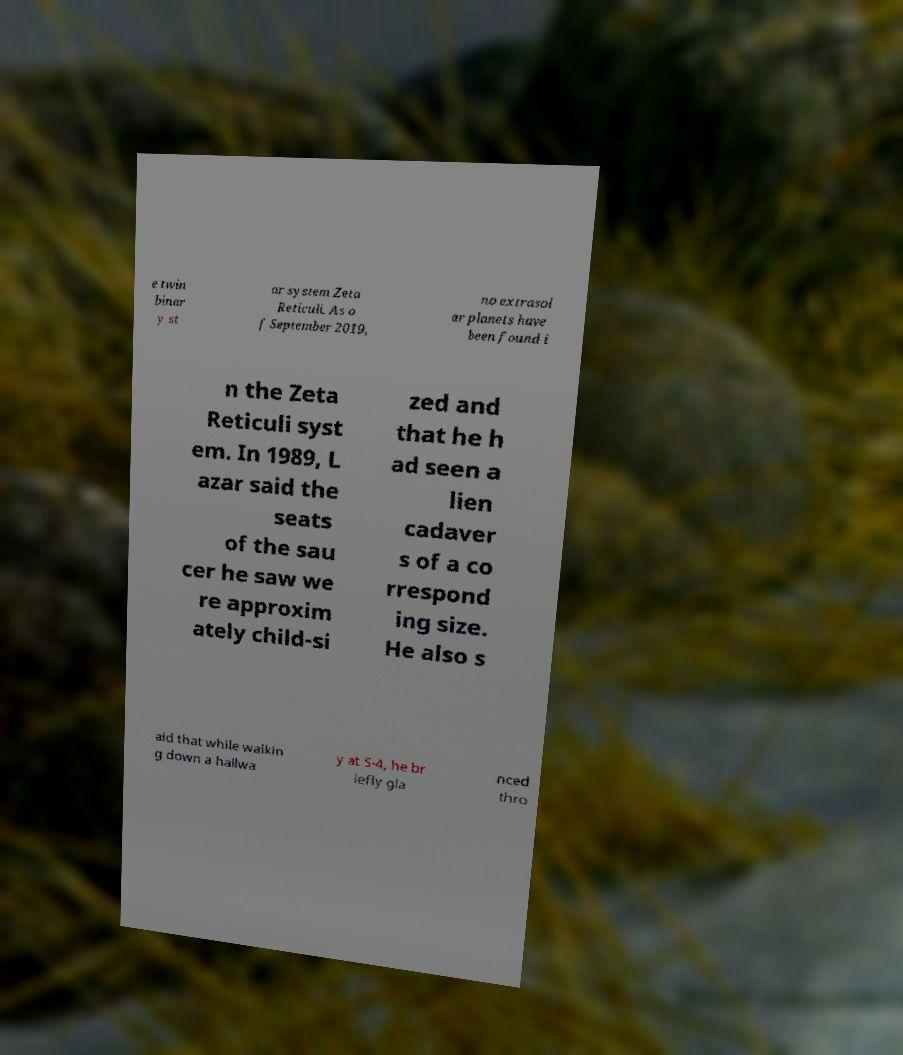Please read and relay the text visible in this image. What does it say? e twin binar y st ar system Zeta Reticuli. As o f September 2019, no extrasol ar planets have been found i n the Zeta Reticuli syst em. In 1989, L azar said the seats of the sau cer he saw we re approxim ately child-si zed and that he h ad seen a lien cadaver s of a co rrespond ing size. He also s aid that while walkin g down a hallwa y at S-4, he br iefly gla nced thro 